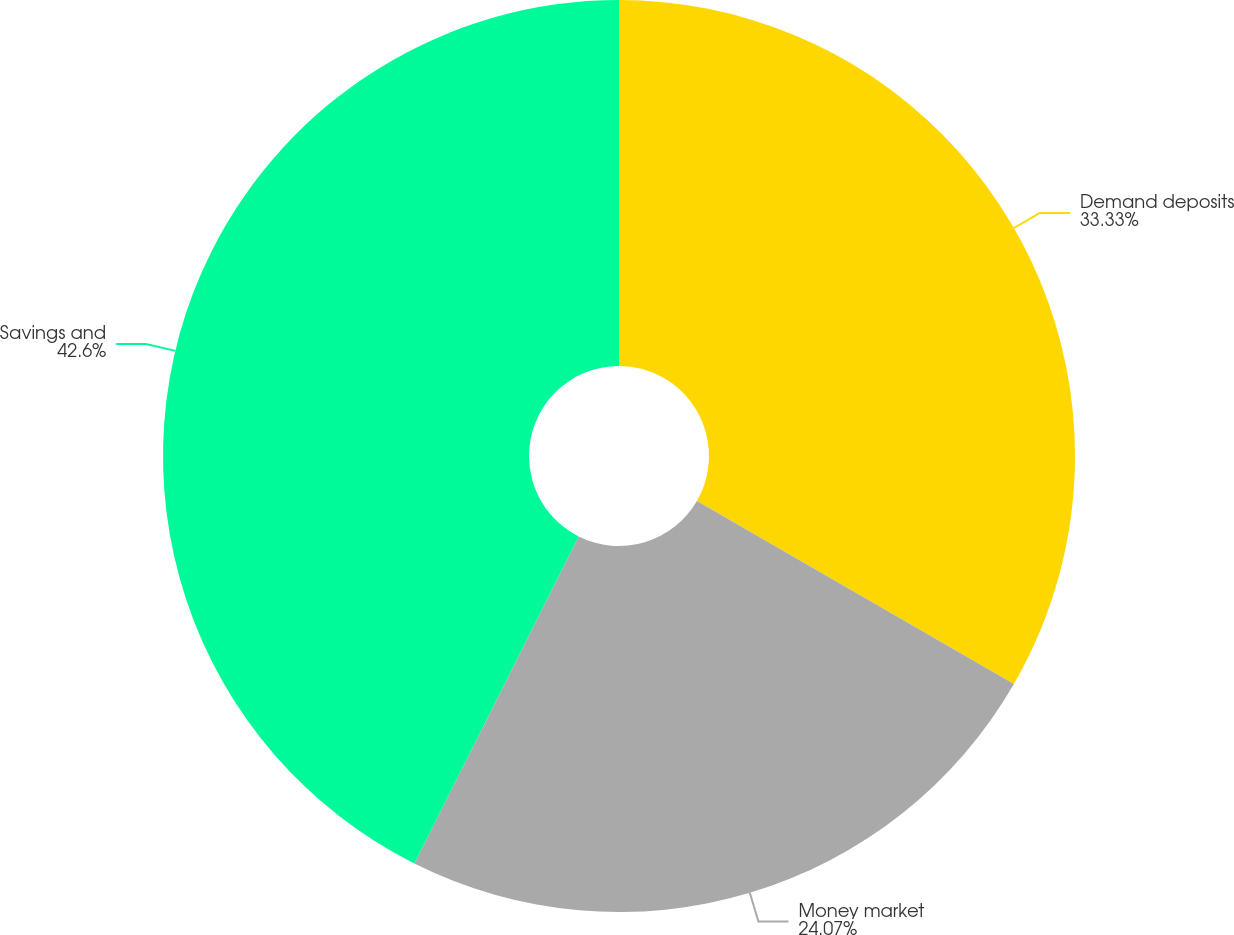<chart> <loc_0><loc_0><loc_500><loc_500><pie_chart><fcel>Demand deposits<fcel>Money market<fcel>Savings and<nl><fcel>33.33%<fcel>24.07%<fcel>42.59%<nl></chart> 